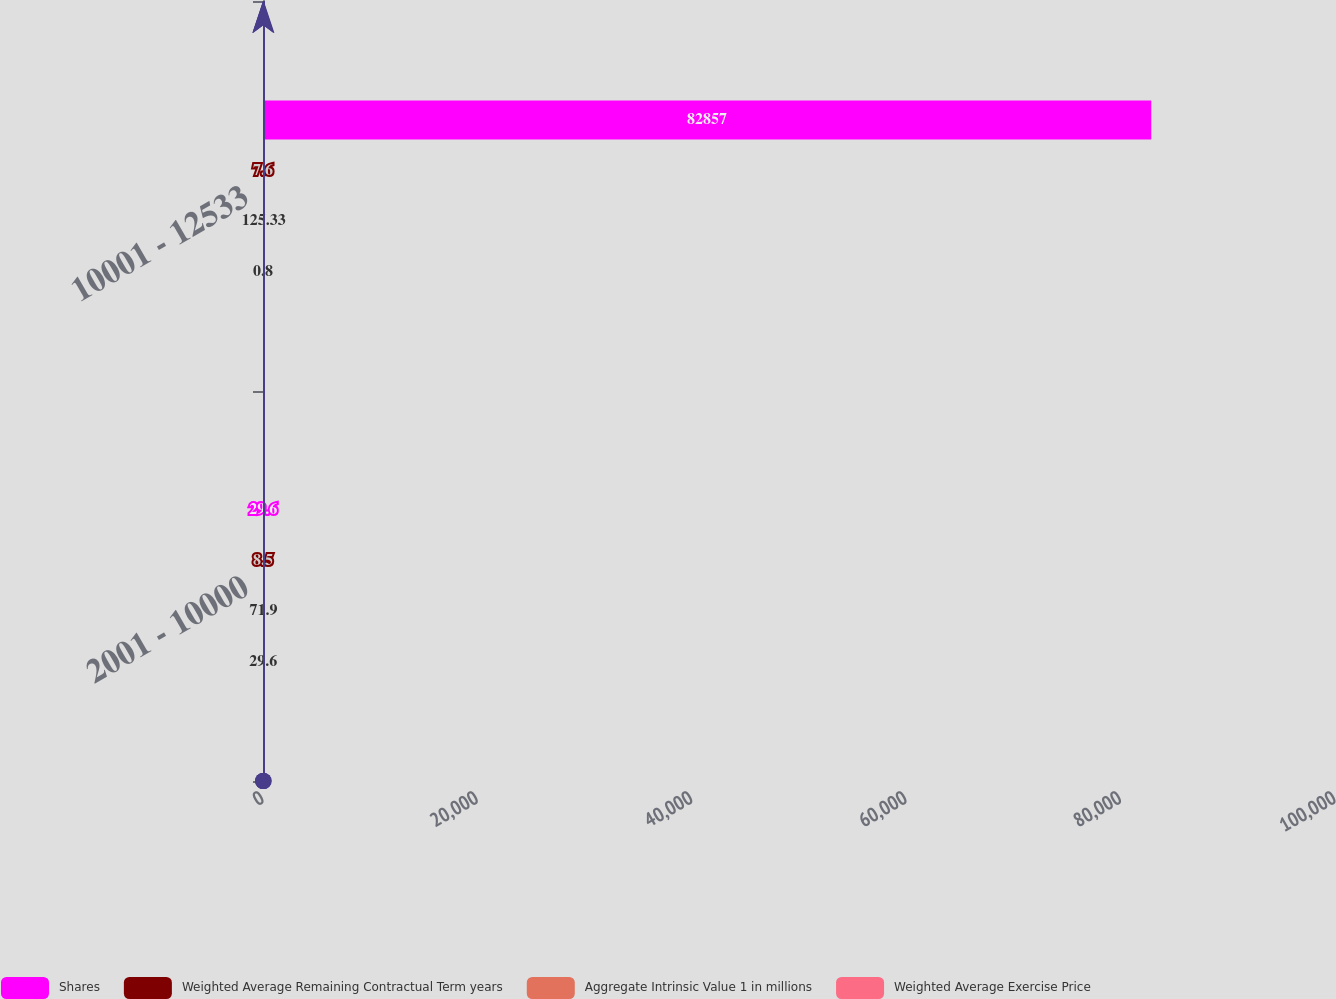Convert chart. <chart><loc_0><loc_0><loc_500><loc_500><stacked_bar_chart><ecel><fcel>2001 - 10000<fcel>10001 - 12533<nl><fcel>Shares<fcel>29.6<fcel>82857<nl><fcel>Weighted Average Remaining Contractual Term years<fcel>8.5<fcel>7.6<nl><fcel>Aggregate Intrinsic Value 1 in millions<fcel>71.9<fcel>125.33<nl><fcel>Weighted Average Exercise Price<fcel>29.6<fcel>0.8<nl></chart> 